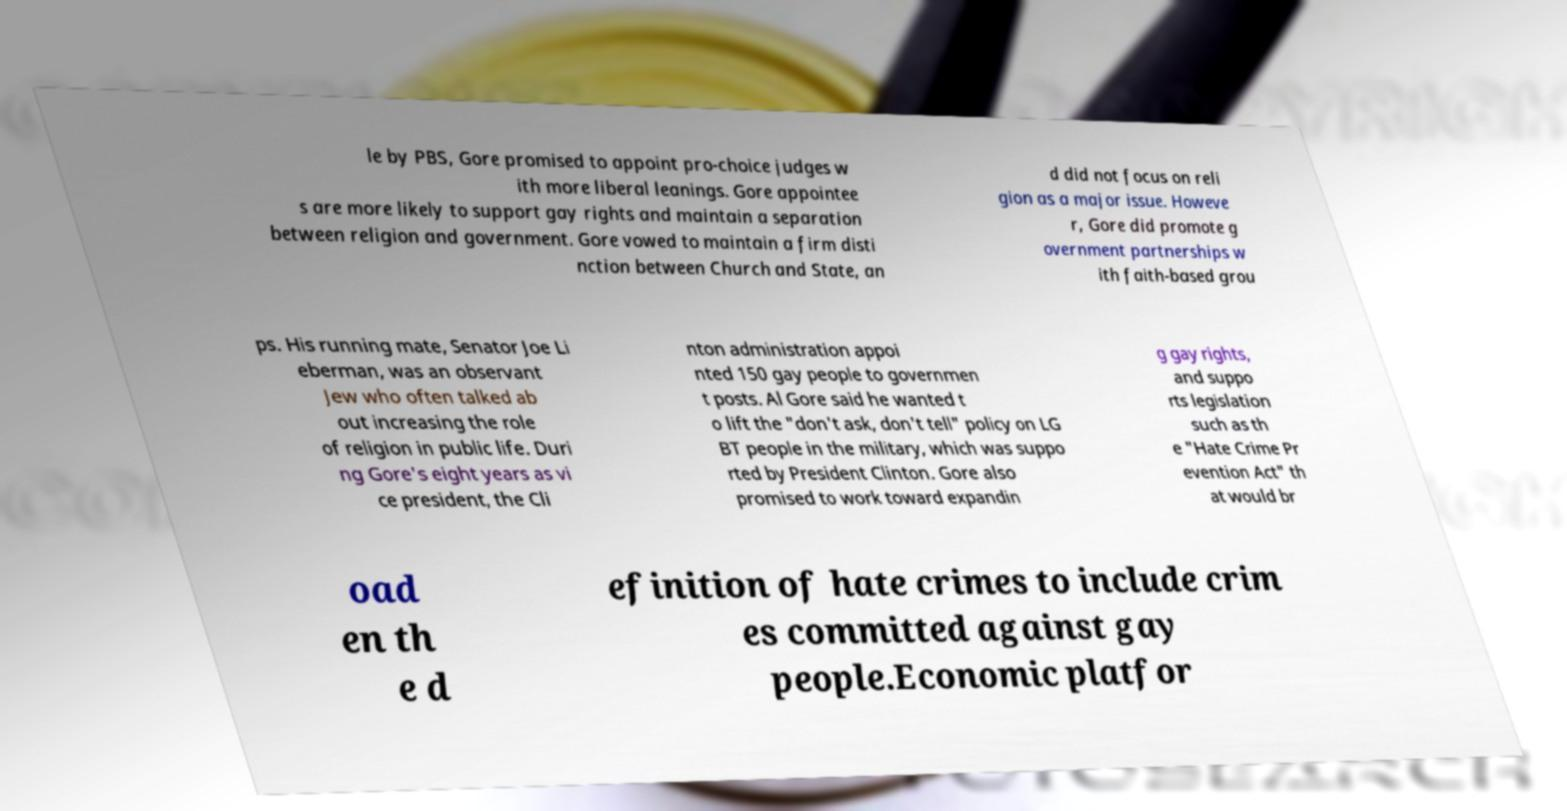Could you extract and type out the text from this image? le by PBS, Gore promised to appoint pro-choice judges w ith more liberal leanings. Gore appointee s are more likely to support gay rights and maintain a separation between religion and government. Gore vowed to maintain a firm disti nction between Church and State, an d did not focus on reli gion as a major issue. Howeve r, Gore did promote g overnment partnerships w ith faith-based grou ps. His running mate, Senator Joe Li eberman, was an observant Jew who often talked ab out increasing the role of religion in public life. Duri ng Gore's eight years as vi ce president, the Cli nton administration appoi nted 150 gay people to governmen t posts. Al Gore said he wanted t o lift the "don't ask, don't tell" policy on LG BT people in the military, which was suppo rted by President Clinton. Gore also promised to work toward expandin g gay rights, and suppo rts legislation such as th e "Hate Crime Pr evention Act" th at would br oad en th e d efinition of hate crimes to include crim es committed against gay people.Economic platfor 